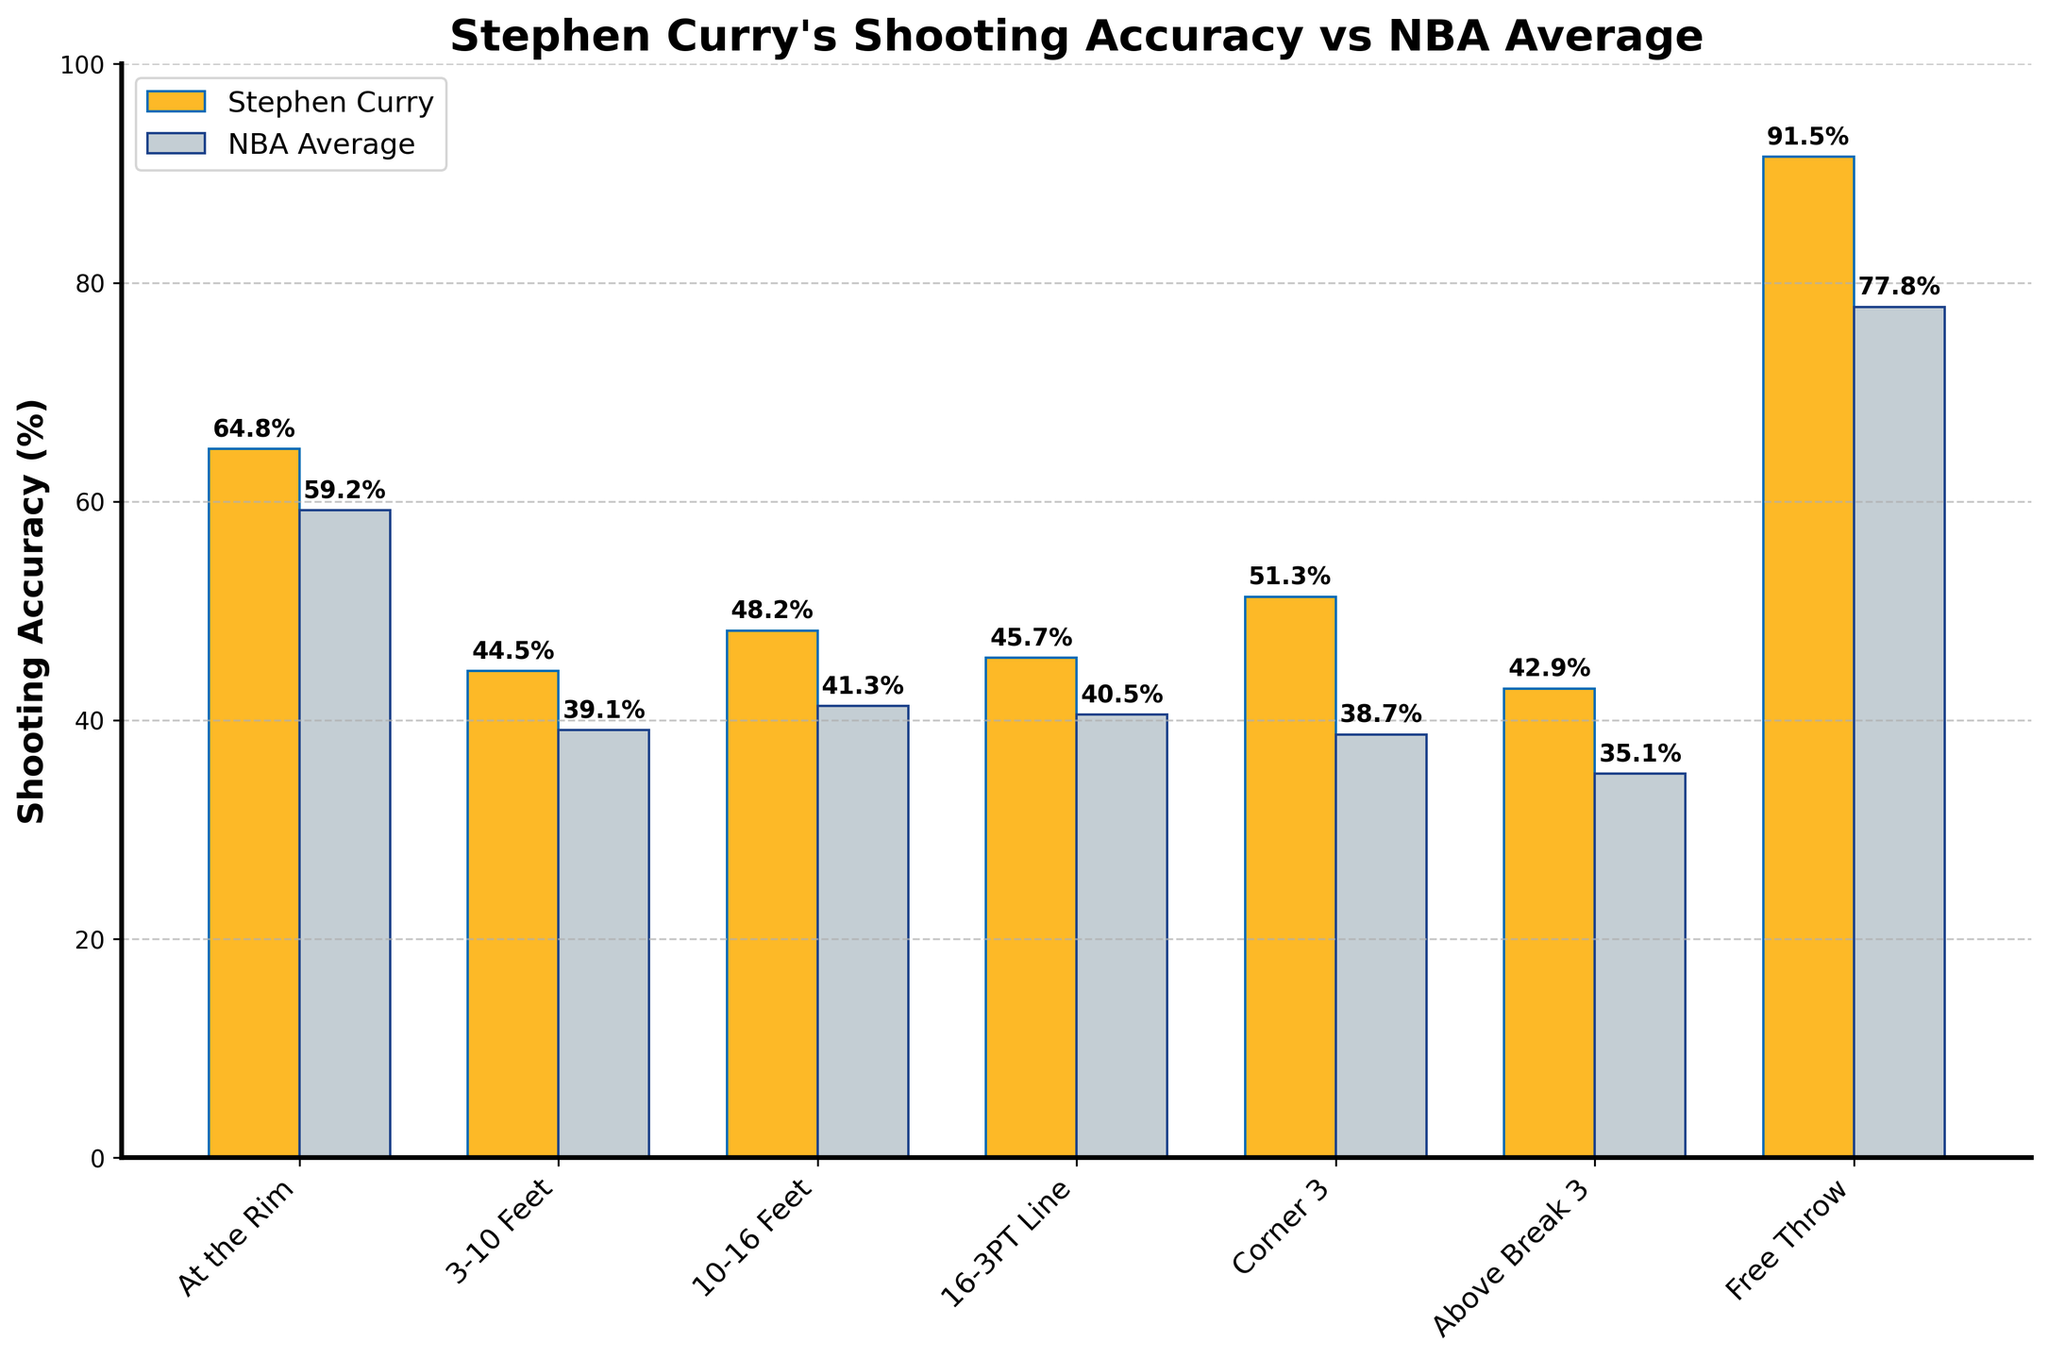What’s the difference in shooting accuracy between Stephen Curry and the NBA average from 3-10 Feet? Stephen Curry’s shooting accuracy from 3-10 feet is 44.5%, and the NBA average is 39.1%. The difference is calculated as 44.5% - 39.1% = 5.4%.
Answer: 5.4% Which shot area shows the biggest gap in shooting accuracy between Stephen Curry and the NBA average? Comparing the differences in shooting accuracy for all shot areas, the biggest gap is for Corner 3, where the difference is 51.3% (Curry) - 38.7% (NBA) = 12.6%.
Answer: Corner 3 What is Stephen Curry’s shooting accuracy above the break 3-point line compared to the NBA average? Stephen Curry’s shooting accuracy from above the break 3-point line is 42.9%. The NBA average for the same is 35.1%. Thus, Curry's shooting accuracy from this area is higher by 7.8%.
Answer: 42.9%, 35.1% Which shooting area has the lowest shooting accuracy for Stephen Curry? By observing the heights of the bars representing Stephen Curry's shooting accuracy, the area with the lowest accuracy is Above Break 3, which is 42.9%.
Answer: Above Break 3 How does Stephen Curry’s free throw accuracy compare to the NBA average? Stephen Curry's free throw accuracy is 91.5%, and the NBA average is 77.8%. Curry's free throw percentage is higher by 91.5% - 77.8% = 13.7%.
Answer: 13.7% Compare Stephen Curry’s shooting accuracy at the rim to his accuracy from 3-10 feet. Stephen Curry's shooting accuracy at the rim is 64.8%, while his accuracy from 3-10 feet is 44.5%. Curry has a higher accuracy at the rim by 64.8% - 44.5% = 20.3%.
Answer: 20.3% Which areas of the court does Curry outperform the NBA average the most and least? Curry outperforms the NBA average the most in the Corner 3 area by a difference of 12.6%. The area where he outperforms the least is 3-10 Feet with a difference of 5.4%.
Answer: Corner 3, 3-10 Feet What’s the average shooting accuracy for Stephen Curry across all areas shown in the bar chart? Calculate the average by summing Curry's shooting accuracies from all areas and dividing by the number of areas: (64.8 + 44.5 + 48.2 + 45.7 + 51.3 + 42.9 + 91.5) / 7 ≈ 55.56%.
Answer: 55.56% What is the visual difference in bar color between Stephen Curry’s shooting accuracy and the NBA average? The bars representing Stephen Curry's shooting accuracy are golden with blue edges, while the NBA average bars are grey with blue edges.
Answer: Golden with blue edges, Grey with blue edges Which shooting area has the smallest gap between Curry's shooting accuracy and the NBA average, excluding free throws? Excluding free throws, the smallest gap is in the 3-10 Feet range. The difference in this area is 5.4% (44.5% - 39.1%).
Answer: 3-10 Feet 